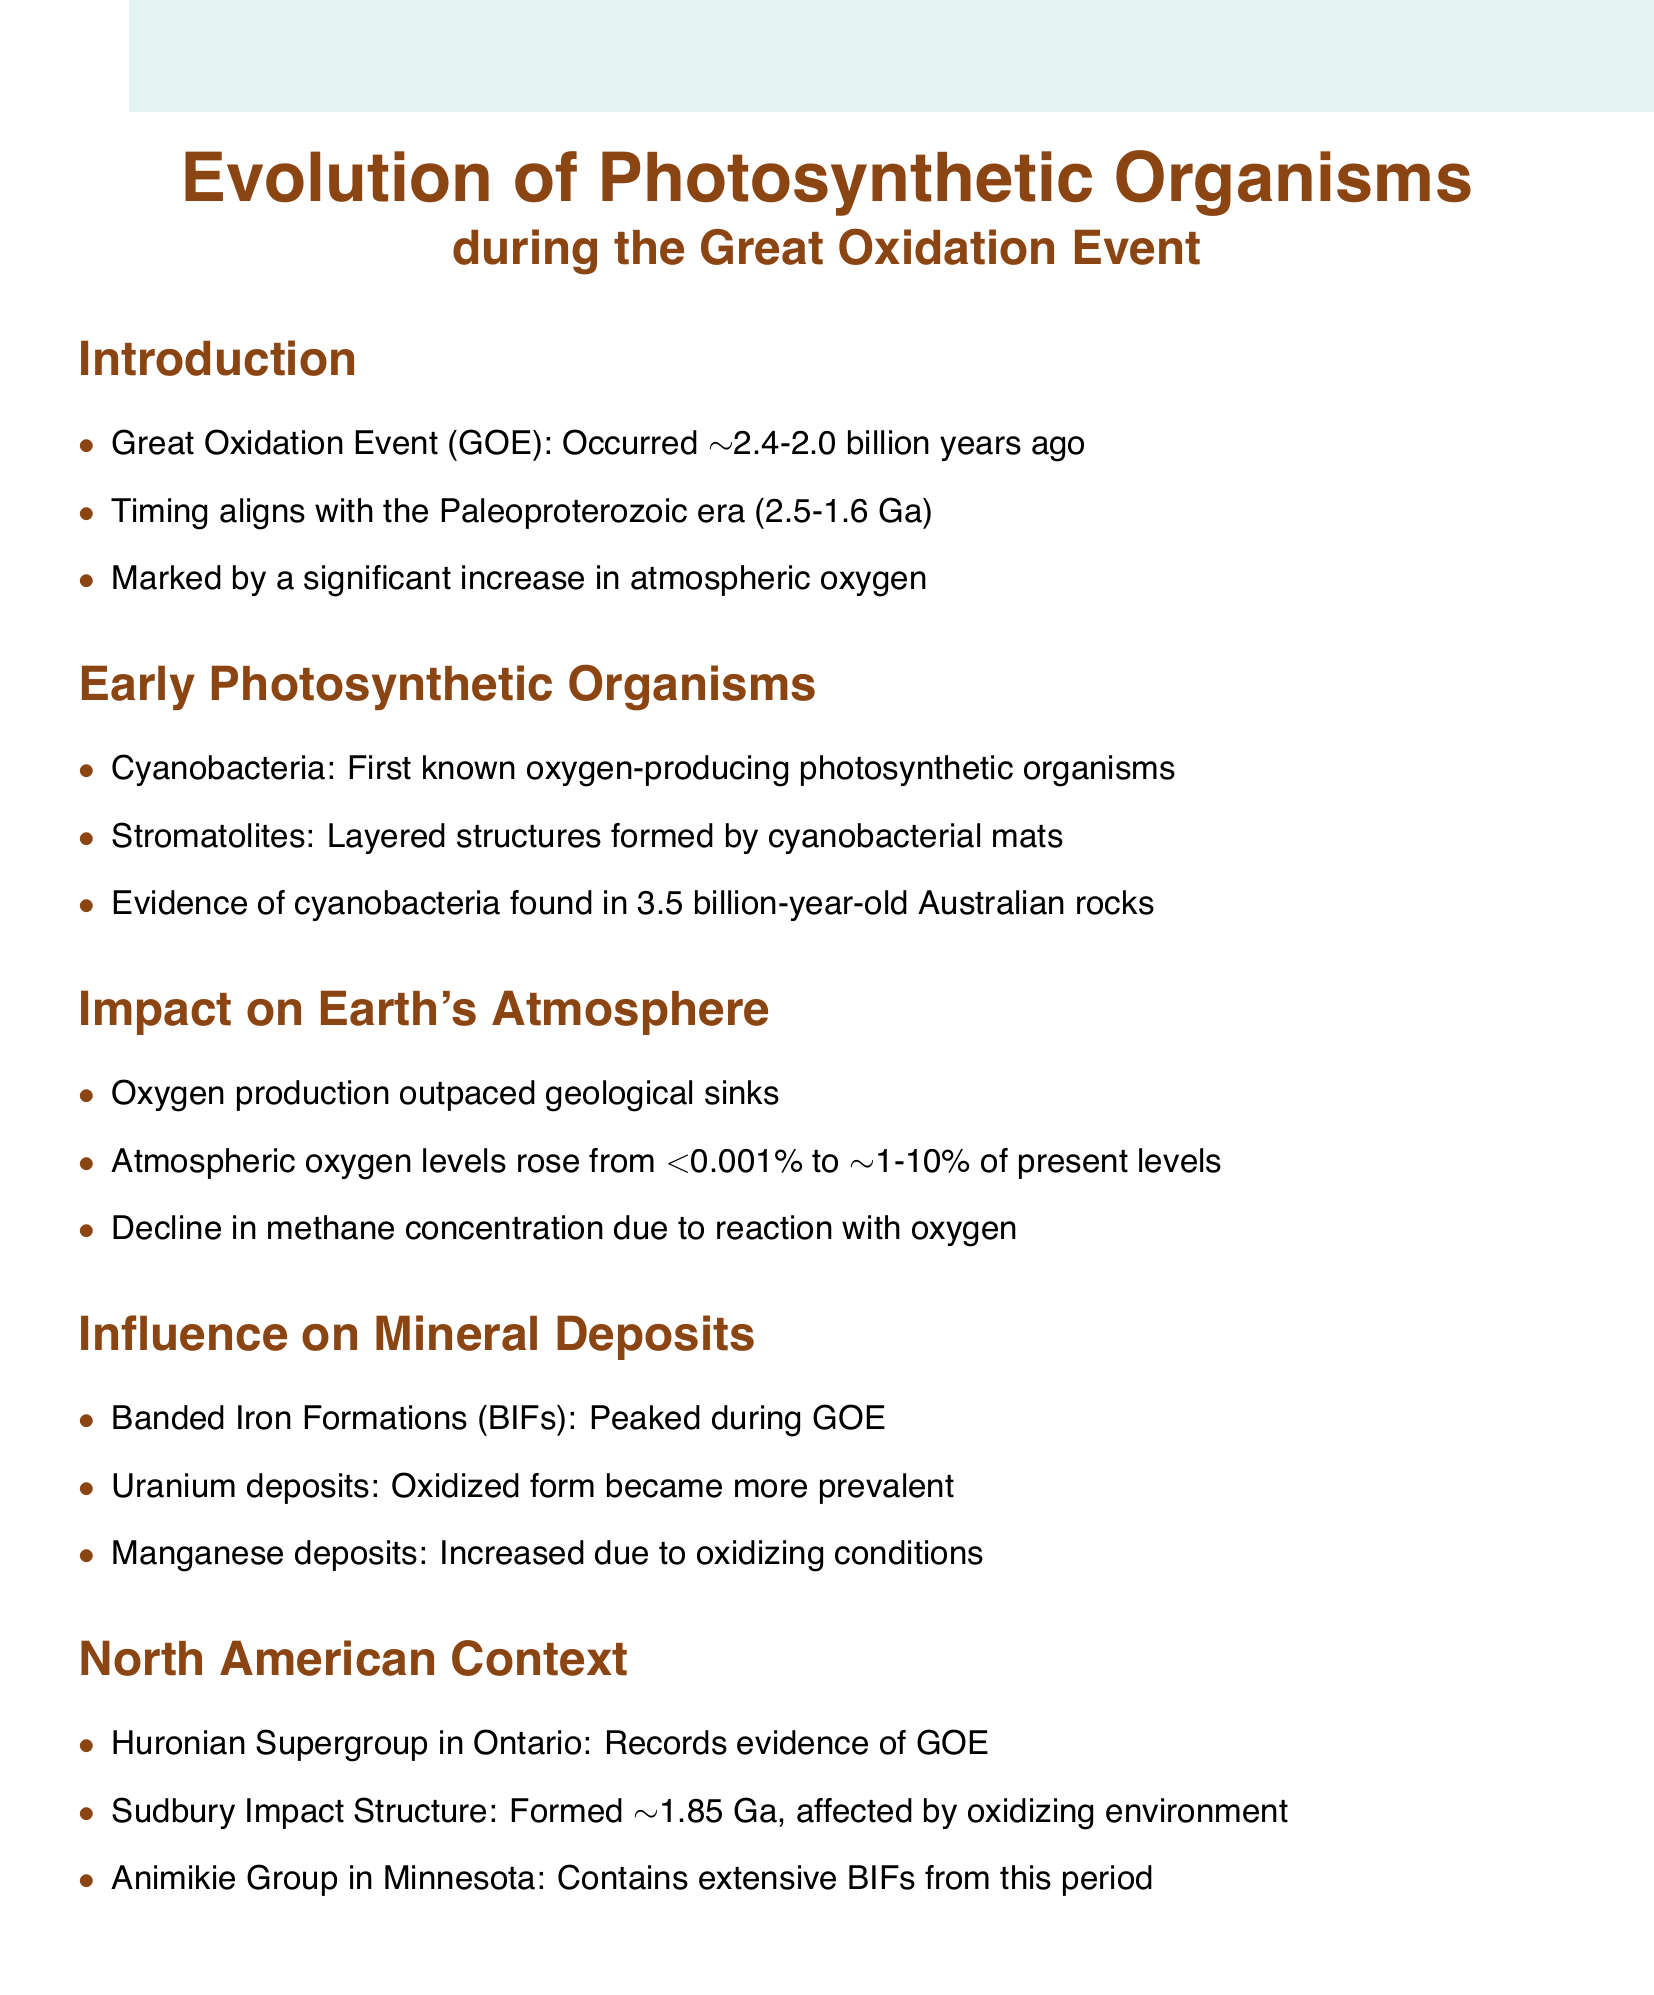What is the time frame for the Great Oxidation Event? The document states that the Great Oxidation Event occurred from approximately 2.4 to 2.0 billion years ago.
Answer: 2.4-2.0 billion years ago Which organism is identified as the first known oxygen-producing photosynthetic organism? According to the document, cyanobacteria are identified as the first known oxygen-producing photosynthetic organisms.
Answer: Cyanobacteria What is the major mineral deposit type that peaked during the Great Oxidation Event? The document mentions that Banded Iron Formations (BIFs) peaked during the Great Oxidation Event.
Answer: Banded Iron Formations (BIFs) What significant change occurred in atmospheric oxygen levels during the GOE? The document indicates that atmospheric oxygen levels rose from less than 0.001% to approximately 1-10% of present levels.
Answer: <0.001% to ~1-10% of present levels Which geological formation in Ontario records evidence of the Great Oxidation Event? The Huronian Supergroup in Ontario is specifically mentioned as recording evidence of the Great Oxidation Event.
Answer: Huronian Supergroup What effect did the Great Oxidation Event have on methane concentration? According to the document, there was a decline in methane concentration due to its reaction with oxygen during the GOE.
Answer: Decline in methane concentration What age is the Sudbury Impact Structure? The document states that the Sudbury Impact Structure formed about 1.85 billion years ago.
Answer: ~1.85 billion years ago What environmental condition led to an increase in manganese deposits during the GOE? The document explains that manganese deposits increased due to oxidizing conditions present during the Great Oxidation Event.
Answer: Oxidizing conditions 